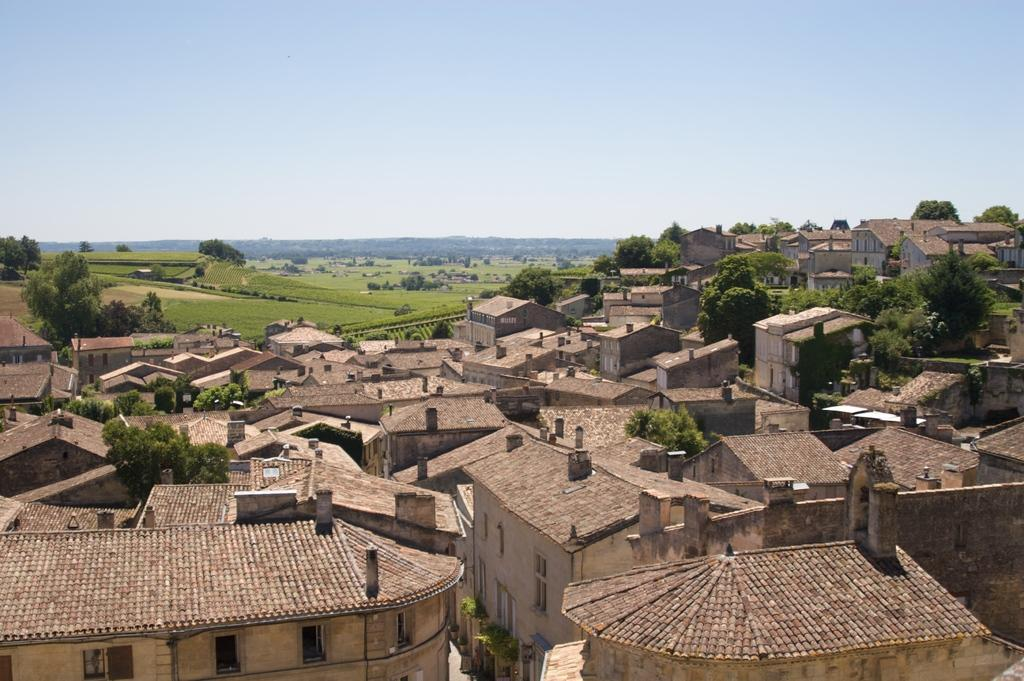What type of structures can be seen in the image? There are houses in the image. What can be seen in the background of the image? There are trees and the sky visible in the background of the image. How many rabbits are hopping around in the image? There are no rabbits present in the image. What type of shirt is the power line wearing in the image? There are no shirts or power lines present in the image. 